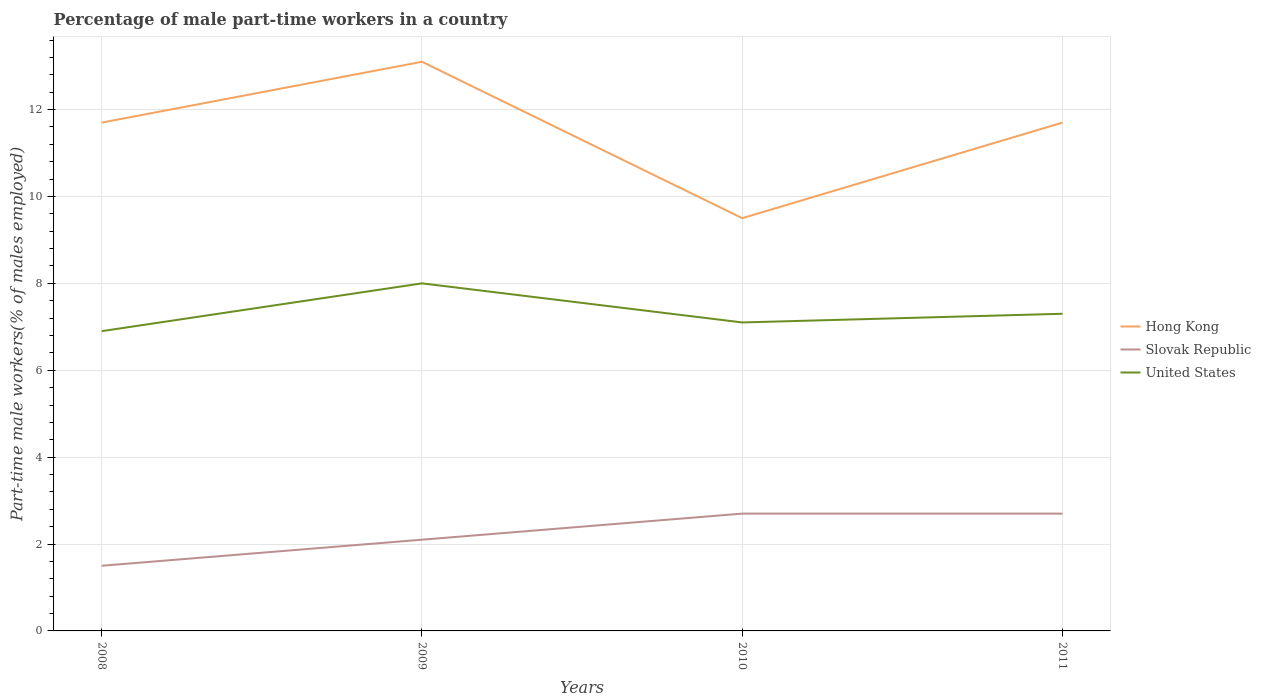How many different coloured lines are there?
Offer a terse response. 3. Does the line corresponding to Hong Kong intersect with the line corresponding to Slovak Republic?
Your response must be concise. No. Across all years, what is the maximum percentage of male part-time workers in Hong Kong?
Provide a succinct answer. 9.5. What is the total percentage of male part-time workers in Hong Kong in the graph?
Your answer should be very brief. 0. What is the difference between the highest and the second highest percentage of male part-time workers in Hong Kong?
Your answer should be compact. 3.6. What is the difference between the highest and the lowest percentage of male part-time workers in Slovak Republic?
Provide a short and direct response. 2. How many years are there in the graph?
Make the answer very short. 4. Does the graph contain grids?
Your response must be concise. Yes. How are the legend labels stacked?
Your answer should be very brief. Vertical. What is the title of the graph?
Keep it short and to the point. Percentage of male part-time workers in a country. What is the label or title of the Y-axis?
Ensure brevity in your answer.  Part-time male workers(% of males employed). What is the Part-time male workers(% of males employed) of Hong Kong in 2008?
Make the answer very short. 11.7. What is the Part-time male workers(% of males employed) in United States in 2008?
Your answer should be very brief. 6.9. What is the Part-time male workers(% of males employed) of Hong Kong in 2009?
Provide a succinct answer. 13.1. What is the Part-time male workers(% of males employed) of Slovak Republic in 2009?
Provide a succinct answer. 2.1. What is the Part-time male workers(% of males employed) of United States in 2009?
Offer a terse response. 8. What is the Part-time male workers(% of males employed) of Hong Kong in 2010?
Ensure brevity in your answer.  9.5. What is the Part-time male workers(% of males employed) in Slovak Republic in 2010?
Your response must be concise. 2.7. What is the Part-time male workers(% of males employed) of United States in 2010?
Offer a terse response. 7.1. What is the Part-time male workers(% of males employed) of Hong Kong in 2011?
Give a very brief answer. 11.7. What is the Part-time male workers(% of males employed) of Slovak Republic in 2011?
Your answer should be very brief. 2.7. What is the Part-time male workers(% of males employed) in United States in 2011?
Your answer should be compact. 7.3. Across all years, what is the maximum Part-time male workers(% of males employed) of Hong Kong?
Your answer should be compact. 13.1. Across all years, what is the maximum Part-time male workers(% of males employed) in Slovak Republic?
Your response must be concise. 2.7. Across all years, what is the minimum Part-time male workers(% of males employed) of Slovak Republic?
Offer a terse response. 1.5. Across all years, what is the minimum Part-time male workers(% of males employed) of United States?
Offer a terse response. 6.9. What is the total Part-time male workers(% of males employed) of Slovak Republic in the graph?
Your answer should be very brief. 9. What is the total Part-time male workers(% of males employed) in United States in the graph?
Give a very brief answer. 29.3. What is the difference between the Part-time male workers(% of males employed) in Hong Kong in 2008 and that in 2010?
Your response must be concise. 2.2. What is the difference between the Part-time male workers(% of males employed) in United States in 2008 and that in 2010?
Give a very brief answer. -0.2. What is the difference between the Part-time male workers(% of males employed) of Hong Kong in 2008 and that in 2011?
Give a very brief answer. 0. What is the difference between the Part-time male workers(% of males employed) of Slovak Republic in 2008 and that in 2011?
Keep it short and to the point. -1.2. What is the difference between the Part-time male workers(% of males employed) in Slovak Republic in 2009 and that in 2010?
Give a very brief answer. -0.6. What is the difference between the Part-time male workers(% of males employed) in Hong Kong in 2009 and that in 2011?
Your answer should be very brief. 1.4. What is the difference between the Part-time male workers(% of males employed) in Slovak Republic in 2009 and that in 2011?
Your answer should be very brief. -0.6. What is the difference between the Part-time male workers(% of males employed) in Slovak Republic in 2008 and the Part-time male workers(% of males employed) in United States in 2009?
Keep it short and to the point. -6.5. What is the difference between the Part-time male workers(% of males employed) of Hong Kong in 2008 and the Part-time male workers(% of males employed) of United States in 2010?
Provide a succinct answer. 4.6. What is the difference between the Part-time male workers(% of males employed) in Hong Kong in 2008 and the Part-time male workers(% of males employed) in United States in 2011?
Your answer should be compact. 4.4. What is the difference between the Part-time male workers(% of males employed) of Hong Kong in 2009 and the Part-time male workers(% of males employed) of Slovak Republic in 2010?
Give a very brief answer. 10.4. What is the difference between the Part-time male workers(% of males employed) of Hong Kong in 2009 and the Part-time male workers(% of males employed) of Slovak Republic in 2011?
Provide a succinct answer. 10.4. What is the difference between the Part-time male workers(% of males employed) of Hong Kong in 2009 and the Part-time male workers(% of males employed) of United States in 2011?
Give a very brief answer. 5.8. What is the difference between the Part-time male workers(% of males employed) of Hong Kong in 2010 and the Part-time male workers(% of males employed) of Slovak Republic in 2011?
Give a very brief answer. 6.8. What is the difference between the Part-time male workers(% of males employed) in Slovak Republic in 2010 and the Part-time male workers(% of males employed) in United States in 2011?
Offer a very short reply. -4.6. What is the average Part-time male workers(% of males employed) of Hong Kong per year?
Provide a succinct answer. 11.5. What is the average Part-time male workers(% of males employed) of Slovak Republic per year?
Your response must be concise. 2.25. What is the average Part-time male workers(% of males employed) of United States per year?
Your answer should be compact. 7.33. In the year 2008, what is the difference between the Part-time male workers(% of males employed) of Hong Kong and Part-time male workers(% of males employed) of Slovak Republic?
Your response must be concise. 10.2. In the year 2008, what is the difference between the Part-time male workers(% of males employed) in Hong Kong and Part-time male workers(% of males employed) in United States?
Offer a very short reply. 4.8. In the year 2009, what is the difference between the Part-time male workers(% of males employed) in Slovak Republic and Part-time male workers(% of males employed) in United States?
Provide a short and direct response. -5.9. In the year 2010, what is the difference between the Part-time male workers(% of males employed) of Hong Kong and Part-time male workers(% of males employed) of Slovak Republic?
Keep it short and to the point. 6.8. In the year 2010, what is the difference between the Part-time male workers(% of males employed) in Slovak Republic and Part-time male workers(% of males employed) in United States?
Provide a short and direct response. -4.4. In the year 2011, what is the difference between the Part-time male workers(% of males employed) of Hong Kong and Part-time male workers(% of males employed) of Slovak Republic?
Provide a short and direct response. 9. In the year 2011, what is the difference between the Part-time male workers(% of males employed) of Slovak Republic and Part-time male workers(% of males employed) of United States?
Your answer should be compact. -4.6. What is the ratio of the Part-time male workers(% of males employed) of Hong Kong in 2008 to that in 2009?
Offer a very short reply. 0.89. What is the ratio of the Part-time male workers(% of males employed) in Slovak Republic in 2008 to that in 2009?
Your answer should be compact. 0.71. What is the ratio of the Part-time male workers(% of males employed) in United States in 2008 to that in 2009?
Provide a succinct answer. 0.86. What is the ratio of the Part-time male workers(% of males employed) of Hong Kong in 2008 to that in 2010?
Ensure brevity in your answer.  1.23. What is the ratio of the Part-time male workers(% of males employed) in Slovak Republic in 2008 to that in 2010?
Offer a terse response. 0.56. What is the ratio of the Part-time male workers(% of males employed) of United States in 2008 to that in 2010?
Keep it short and to the point. 0.97. What is the ratio of the Part-time male workers(% of males employed) of Slovak Republic in 2008 to that in 2011?
Provide a short and direct response. 0.56. What is the ratio of the Part-time male workers(% of males employed) in United States in 2008 to that in 2011?
Provide a short and direct response. 0.95. What is the ratio of the Part-time male workers(% of males employed) of Hong Kong in 2009 to that in 2010?
Keep it short and to the point. 1.38. What is the ratio of the Part-time male workers(% of males employed) in Slovak Republic in 2009 to that in 2010?
Keep it short and to the point. 0.78. What is the ratio of the Part-time male workers(% of males employed) of United States in 2009 to that in 2010?
Give a very brief answer. 1.13. What is the ratio of the Part-time male workers(% of males employed) of Hong Kong in 2009 to that in 2011?
Provide a short and direct response. 1.12. What is the ratio of the Part-time male workers(% of males employed) in Slovak Republic in 2009 to that in 2011?
Give a very brief answer. 0.78. What is the ratio of the Part-time male workers(% of males employed) of United States in 2009 to that in 2011?
Give a very brief answer. 1.1. What is the ratio of the Part-time male workers(% of males employed) in Hong Kong in 2010 to that in 2011?
Provide a short and direct response. 0.81. What is the ratio of the Part-time male workers(% of males employed) of United States in 2010 to that in 2011?
Your answer should be compact. 0.97. What is the difference between the highest and the second highest Part-time male workers(% of males employed) in Slovak Republic?
Offer a very short reply. 0. What is the difference between the highest and the lowest Part-time male workers(% of males employed) in Slovak Republic?
Give a very brief answer. 1.2. 